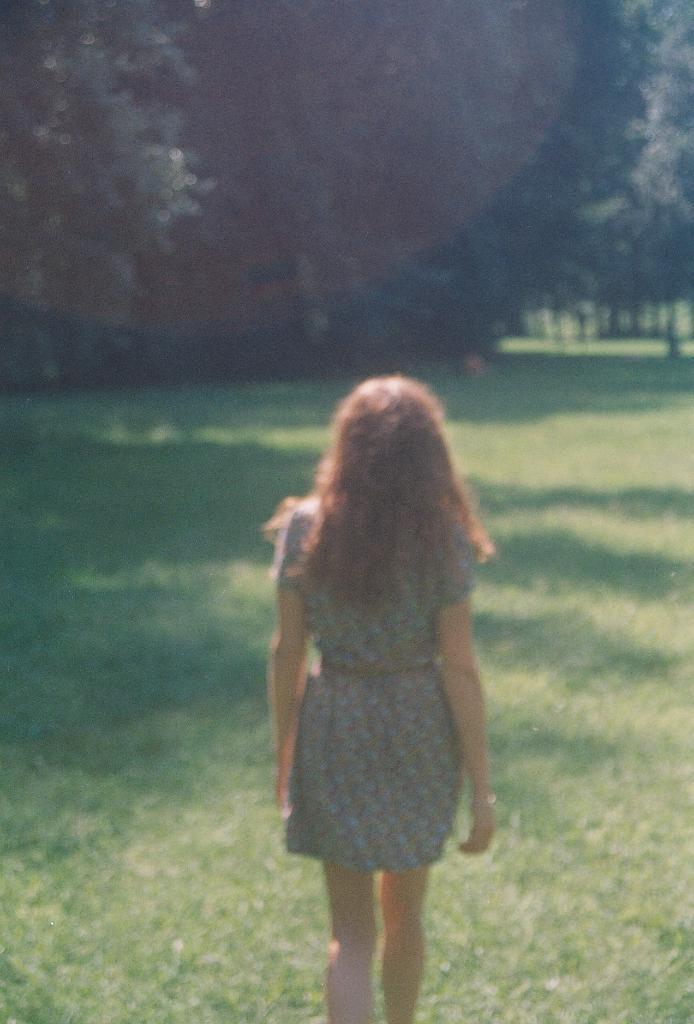Can you describe this image briefly? In this image we can see a woman from the backwards standing on the ground. At the top of the image we can see trees. 